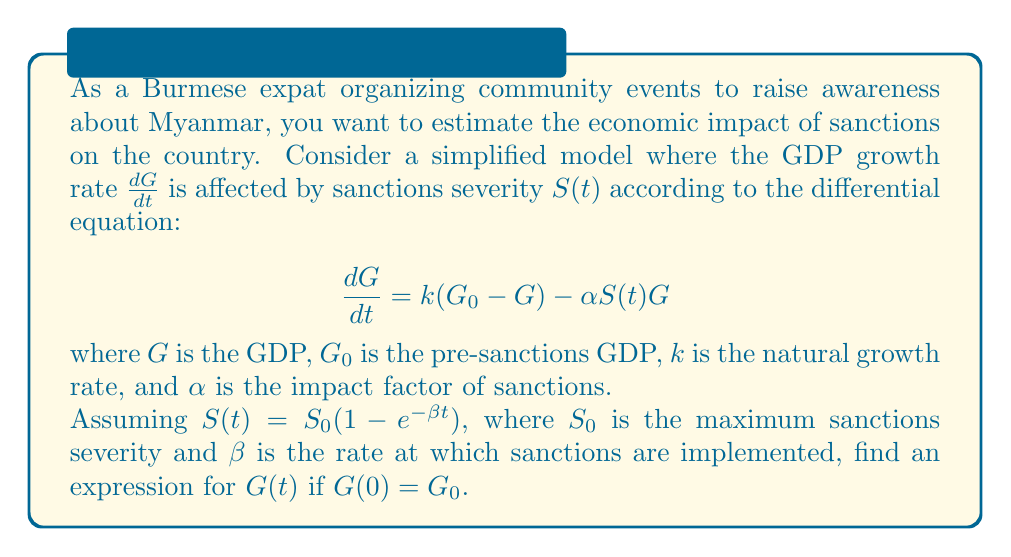Could you help me with this problem? Let's solve this step-by-step:

1) The differential equation is:
   $$\frac{dG}{dt} = k(G_0 - G) - \alpha S(t)G$$

2) Substitute $S(t) = S_0(1 - e^{-\beta t})$:
   $$\frac{dG}{dt} = k(G_0 - G) - \alpha S_0(1 - e^{-\beta t})G$$

3) Rearrange the equation:
   $$\frac{dG}{dt} + (k + \alpha S_0 - \alpha S_0e^{-\beta t})G = kG_0$$

4) This is a linear first-order differential equation of the form:
   $$\frac{dy}{dx} + P(x)y = Q(x)$$

   Where $P(x) = k + \alpha S_0 - \alpha S_0e^{-\beta t}$ and $Q(x) = kG_0$

5) The integrating factor is:
   $$\mu(t) = e^{\int P(t) dt} = e^{kt + \alpha S_0t + \frac{\alpha S_0}{\beta}e^{-\beta t}}$$

6) Multiply both sides of the equation by $\mu(t)$:
   $$\mu(t)\frac{dG}{dt} + \mu(t)(k + \alpha S_0 - \alpha S_0e^{-\beta t})G = \mu(t)kG_0$$

7) This can be written as:
   $$\frac{d}{dt}(\mu(t)G) = \mu(t)kG_0$$

8) Integrate both sides:
   $$\mu(t)G = \int \mu(t)kG_0 dt + C$$

9) Solve for $G$:
   $$G(t) = \frac{\int \mu(t)kG_0 dt + C}{\mu(t)}$$

10) Apply the initial condition $G(0) = G_0$ to find $C$:
    $$G_0 = \frac{C}{\mu(0)} \implies C = G_0\mu(0)$$

11) Therefore, the final solution is:
    $$G(t) = \frac{\int_0^t \mu(s)kG_0 ds + G_0\mu(0)}{\mu(t)}$$

    $$= G_0\left(\frac{\int_0^t \mu(s)k ds + \mu(0)}{\mu(t)}\right)$$

    where $\mu(t) = e^{kt + \alpha S_0t + \frac{\alpha S_0}{\beta}e^{-\beta t}}$
Answer: $G(t) = G_0\left(\frac{\int_0^t \mu(s)k ds + \mu(0)}{\mu(t)}\right)$, where $\mu(t) = e^{kt + \alpha S_0t + \frac{\alpha S_0}{\beta}e^{-\beta t}}$ 